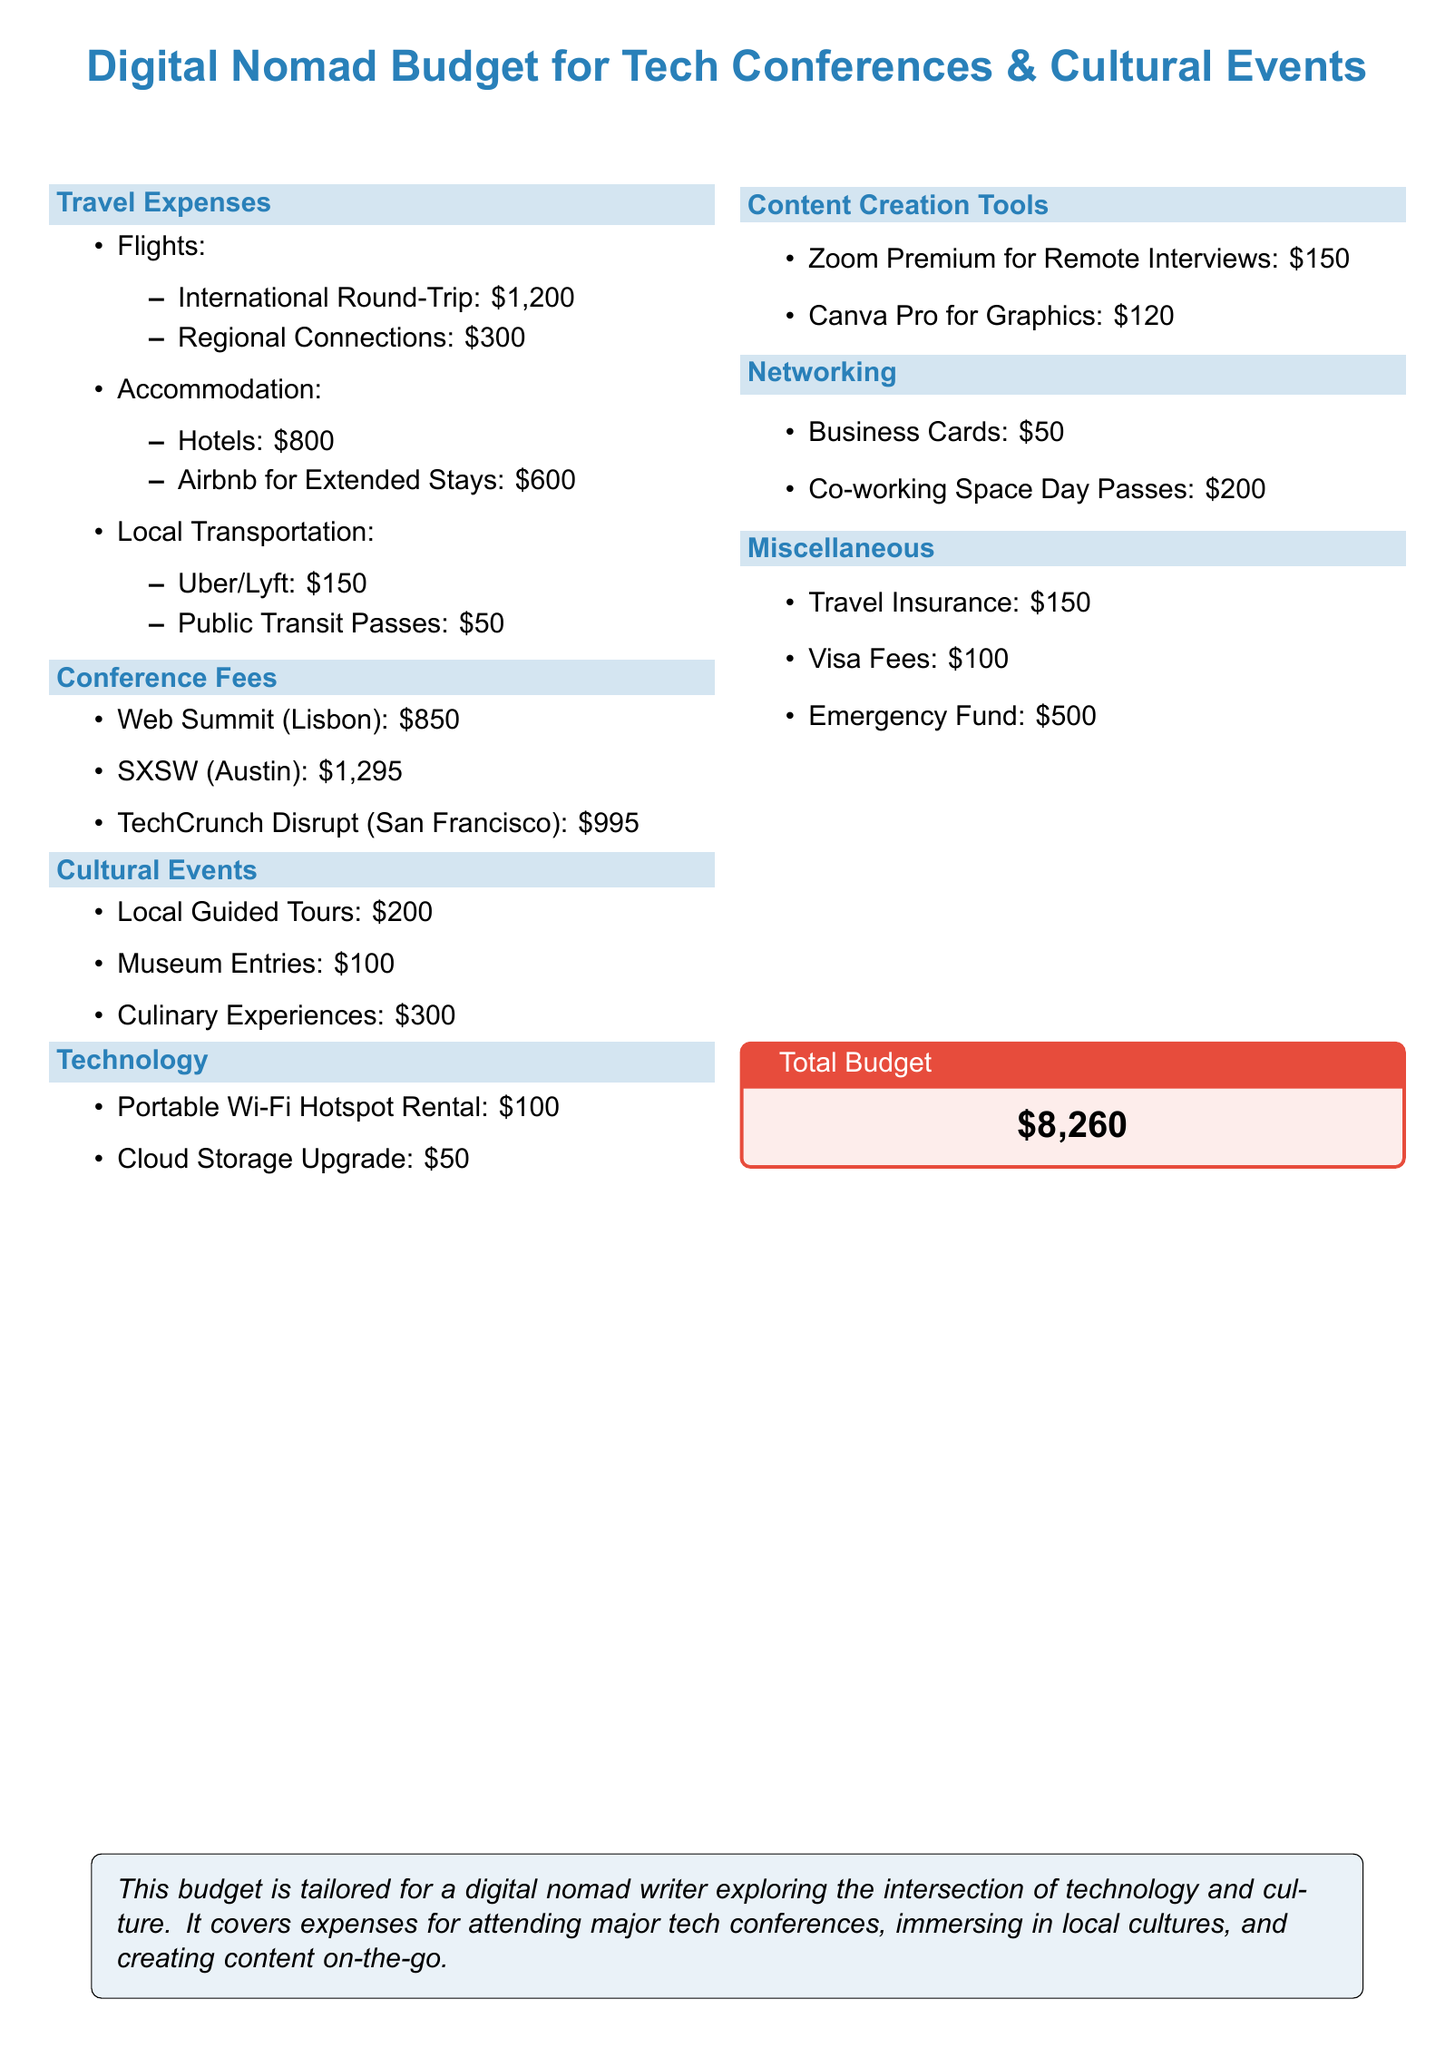What is the total budget? The total budget is presented in the document as the sum of all expenses, which equals $8,260.
Answer: $8,260 How much is the flight for regional connections? The document provides a specific cost for regional connections, which is listed.
Answer: $300 What is the cost of techCrunch Disrupt? The document specifically states the conference fee for TechCrunch Disrupt.
Answer: $995 How much is allocated for emergency funds? Emergency funds are explicitly mentioned in the miscellaneous section with a defined amount.
Answer: $500 What is the cost of local guided tours? The document lists the budget for local guided tours, found under cultural events.
Answer: $200 What is the total cost for accommodation? The total accommodation costs can be determined by adding hotel and Airbnb expenses together.
Answer: $1,400 How much is spent on content creation tools? The document details individual costs for content creation tools, allowing summation of those expenses.
Answer: $270 What is the total cost of travel expenses? The travel expenses can be calculated by adding all listed travel-related costs.
Answer: $2,300 What types of business resources are included in the networking section? The networking section details specific items that help with connecting at events, listed in the document.
Answer: Business Cards, Co-working Space Day Passes 